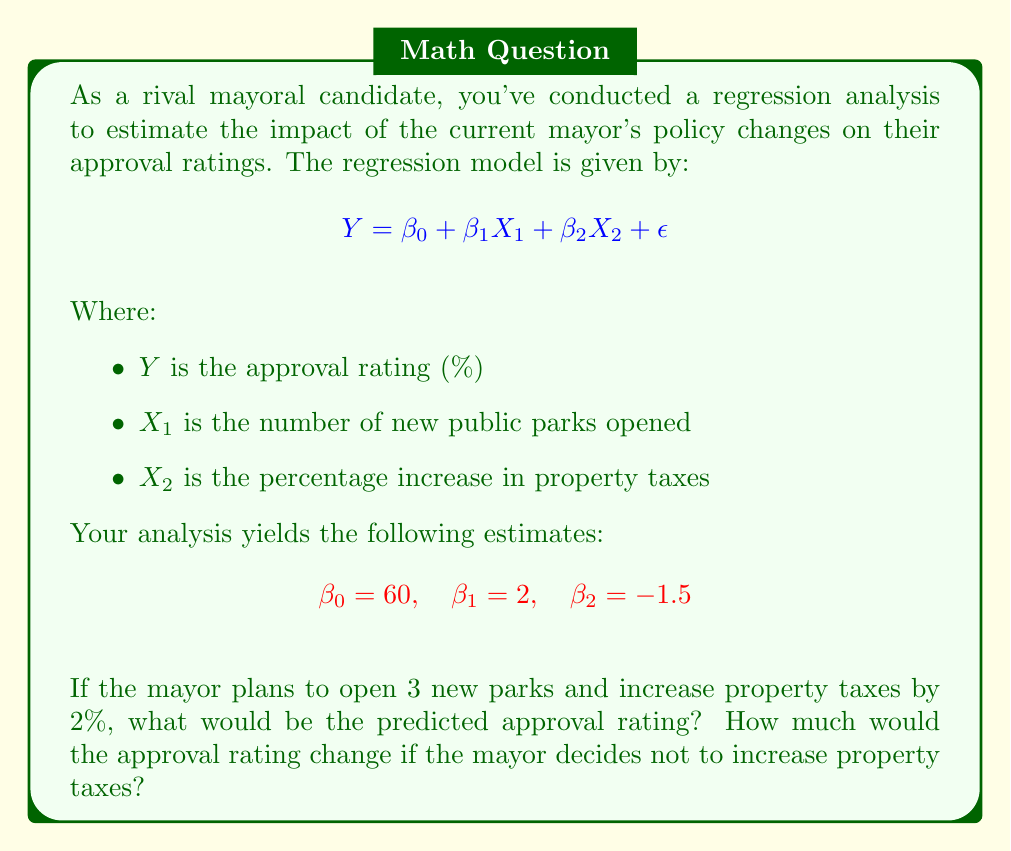Give your solution to this math problem. Let's approach this problem step-by-step:

1) The given regression equation is:

   $$Y = \beta_0 + \beta_1X_1 + \beta_2X_2 + \epsilon$$

2) We're given the following estimates:
   $\beta_0 = 60$ (intercept)
   $\beta_1 = 2$ (coefficient for new parks)
   $\beta_2 = -1.5$ (coefficient for property tax increase)

3) For the first scenario:
   $X_1 = 3$ (3 new parks)
   $X_2 = 2$ (2% increase in property taxes)

4) Let's plug these values into our equation:

   $$Y = 60 + 2(3) + (-1.5)(2)$$

5) Simplify:
   $$Y = 60 + 6 - 3 = 63$$

6) For the second scenario, we keep $X_1 = 3$ but set $X_2 = 0$ (no tax increase):

   $$Y = 60 + 2(3) + (-1.5)(0)$$

7) Simplify:
   $$Y = 60 + 6 + 0 = 66$$

8) The change in approval rating is the difference between these two results:

   $$66 - 63 = 3$$

This analysis shows that by not increasing property taxes, the mayor's predicted approval rating would increase by 3 percentage points.
Answer: The predicted approval rating with 3 new parks and a 2% property tax increase is 63%. If the mayor doesn't increase property taxes, the predicted approval rating would be 66%, a positive change of 3 percentage points. 